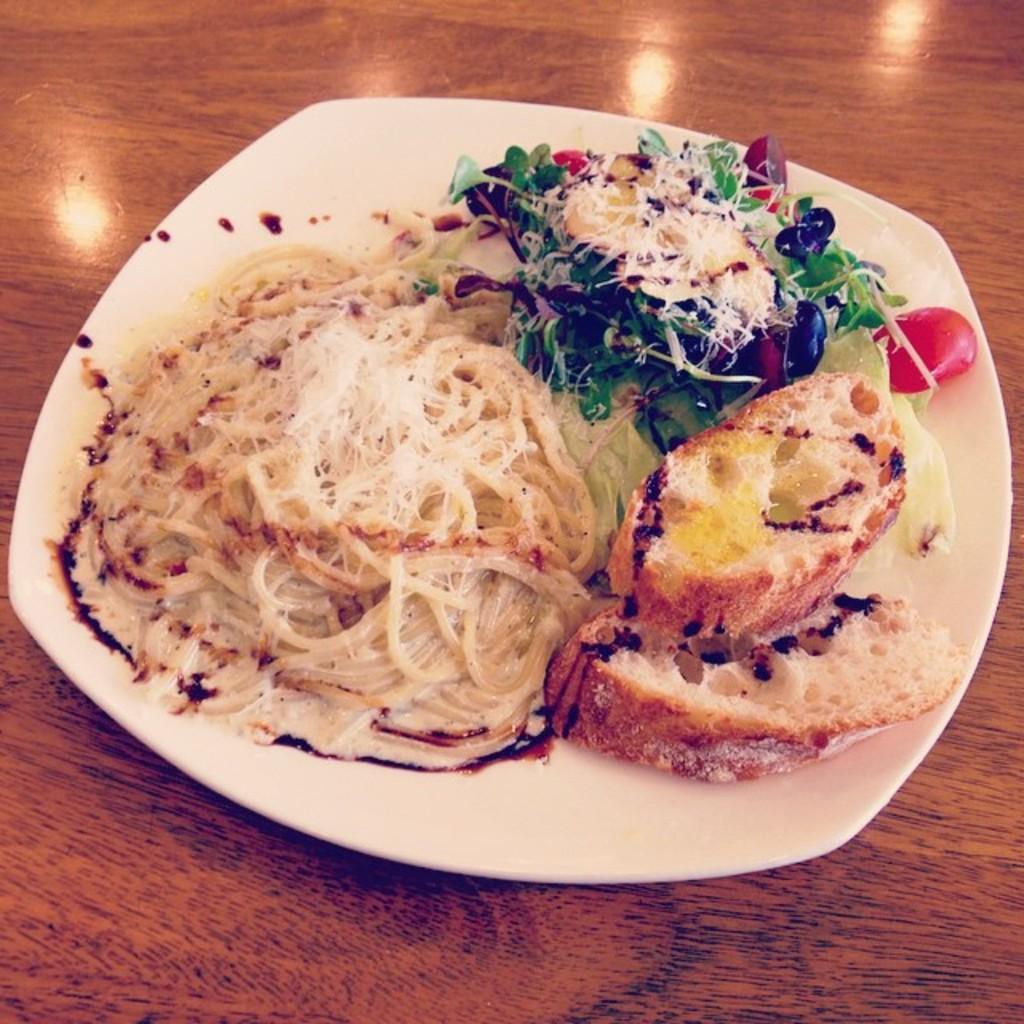How would you summarize this image in a sentence or two? In the image there is some food served on a plate and kept on the table, there are two bread slices, spaghetti and some salad served on the plate. 